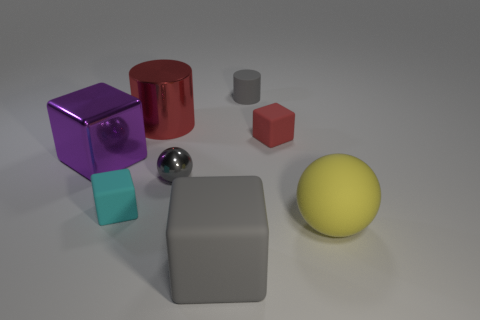The small cube in front of the purple block is what color?
Provide a succinct answer. Cyan. There is a thing that is to the left of the big gray rubber cube and in front of the tiny metal object; how big is it?
Make the answer very short. Small. How many red cubes have the same size as the cyan cube?
Your response must be concise. 1. There is another object that is the same shape as the large yellow rubber thing; what is its material?
Your answer should be very brief. Metal. Do the yellow matte object and the tiny cyan matte object have the same shape?
Your response must be concise. No. There is a large purple cube; how many rubber blocks are behind it?
Your answer should be very brief. 1. There is a red object to the left of the small gray rubber cylinder right of the big shiny cylinder; what shape is it?
Offer a terse response. Cylinder. There is a big purple thing that is the same material as the small gray ball; what shape is it?
Your answer should be very brief. Cube. There is a thing in front of the large ball; is its size the same as the rubber thing that is left of the small shiny ball?
Offer a very short reply. No. There is a tiny rubber thing that is in front of the tiny red cube; what is its shape?
Ensure brevity in your answer.  Cube. 